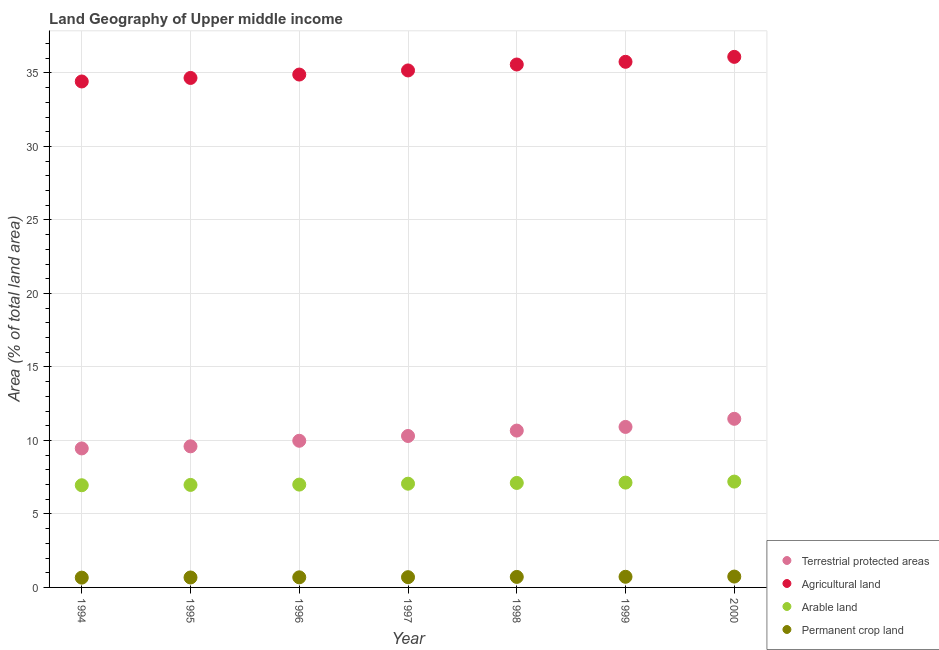How many different coloured dotlines are there?
Ensure brevity in your answer.  4. Is the number of dotlines equal to the number of legend labels?
Provide a short and direct response. Yes. What is the percentage of area under agricultural land in 2000?
Ensure brevity in your answer.  36.09. Across all years, what is the maximum percentage of land under terrestrial protection?
Your response must be concise. 11.47. Across all years, what is the minimum percentage of area under agricultural land?
Keep it short and to the point. 34.42. In which year was the percentage of area under agricultural land maximum?
Your response must be concise. 2000. In which year was the percentage of area under agricultural land minimum?
Make the answer very short. 1994. What is the total percentage of area under permanent crop land in the graph?
Your answer should be very brief. 4.9. What is the difference between the percentage of land under terrestrial protection in 1994 and that in 2000?
Ensure brevity in your answer.  -2.01. What is the difference between the percentage of land under terrestrial protection in 1997 and the percentage of area under arable land in 1996?
Provide a short and direct response. 3.31. What is the average percentage of area under permanent crop land per year?
Make the answer very short. 0.7. In the year 1998, what is the difference between the percentage of land under terrestrial protection and percentage of area under permanent crop land?
Ensure brevity in your answer.  9.95. What is the ratio of the percentage of area under permanent crop land in 1995 to that in 2000?
Offer a very short reply. 0.92. Is the difference between the percentage of area under agricultural land in 1996 and 1999 greater than the difference between the percentage of land under terrestrial protection in 1996 and 1999?
Make the answer very short. Yes. What is the difference between the highest and the second highest percentage of land under terrestrial protection?
Your answer should be very brief. 0.55. What is the difference between the highest and the lowest percentage of area under arable land?
Provide a succinct answer. 0.25. In how many years, is the percentage of land under terrestrial protection greater than the average percentage of land under terrestrial protection taken over all years?
Give a very brief answer. 3. Is the sum of the percentage of area under agricultural land in 1994 and 1997 greater than the maximum percentage of area under arable land across all years?
Provide a succinct answer. Yes. Is it the case that in every year, the sum of the percentage of area under agricultural land and percentage of area under permanent crop land is greater than the sum of percentage of land under terrestrial protection and percentage of area under arable land?
Make the answer very short. Yes. Is it the case that in every year, the sum of the percentage of land under terrestrial protection and percentage of area under agricultural land is greater than the percentage of area under arable land?
Provide a short and direct response. Yes. Is the percentage of area under agricultural land strictly less than the percentage of land under terrestrial protection over the years?
Offer a terse response. No. How many years are there in the graph?
Offer a terse response. 7. Are the values on the major ticks of Y-axis written in scientific E-notation?
Ensure brevity in your answer.  No. Does the graph contain any zero values?
Offer a very short reply. No. Does the graph contain grids?
Offer a very short reply. Yes. Where does the legend appear in the graph?
Make the answer very short. Bottom right. What is the title of the graph?
Offer a very short reply. Land Geography of Upper middle income. What is the label or title of the X-axis?
Provide a succinct answer. Year. What is the label or title of the Y-axis?
Offer a terse response. Area (% of total land area). What is the Area (% of total land area) of Terrestrial protected areas in 1994?
Offer a terse response. 9.46. What is the Area (% of total land area) in Agricultural land in 1994?
Make the answer very short. 34.42. What is the Area (% of total land area) of Arable land in 1994?
Offer a terse response. 6.95. What is the Area (% of total land area) in Permanent crop land in 1994?
Keep it short and to the point. 0.67. What is the Area (% of total land area) of Terrestrial protected areas in 1995?
Ensure brevity in your answer.  9.6. What is the Area (% of total land area) in Agricultural land in 1995?
Offer a terse response. 34.66. What is the Area (% of total land area) in Arable land in 1995?
Your answer should be compact. 6.97. What is the Area (% of total land area) in Permanent crop land in 1995?
Your response must be concise. 0.68. What is the Area (% of total land area) in Terrestrial protected areas in 1996?
Keep it short and to the point. 9.98. What is the Area (% of total land area) in Agricultural land in 1996?
Your answer should be compact. 34.89. What is the Area (% of total land area) of Arable land in 1996?
Offer a very short reply. 7. What is the Area (% of total land area) of Permanent crop land in 1996?
Provide a short and direct response. 0.69. What is the Area (% of total land area) in Terrestrial protected areas in 1997?
Provide a short and direct response. 10.3. What is the Area (% of total land area) in Agricultural land in 1997?
Ensure brevity in your answer.  35.17. What is the Area (% of total land area) in Arable land in 1997?
Your response must be concise. 7.06. What is the Area (% of total land area) of Permanent crop land in 1997?
Offer a terse response. 0.7. What is the Area (% of total land area) in Terrestrial protected areas in 1998?
Give a very brief answer. 10.67. What is the Area (% of total land area) of Agricultural land in 1998?
Your answer should be compact. 35.57. What is the Area (% of total land area) in Arable land in 1998?
Make the answer very short. 7.11. What is the Area (% of total land area) in Permanent crop land in 1998?
Offer a terse response. 0.72. What is the Area (% of total land area) of Terrestrial protected areas in 1999?
Provide a succinct answer. 10.92. What is the Area (% of total land area) of Agricultural land in 1999?
Keep it short and to the point. 35.76. What is the Area (% of total land area) of Arable land in 1999?
Offer a very short reply. 7.13. What is the Area (% of total land area) in Permanent crop land in 1999?
Keep it short and to the point. 0.72. What is the Area (% of total land area) in Terrestrial protected areas in 2000?
Offer a terse response. 11.47. What is the Area (% of total land area) in Agricultural land in 2000?
Keep it short and to the point. 36.09. What is the Area (% of total land area) in Arable land in 2000?
Keep it short and to the point. 7.2. What is the Area (% of total land area) of Permanent crop land in 2000?
Ensure brevity in your answer.  0.74. Across all years, what is the maximum Area (% of total land area) of Terrestrial protected areas?
Offer a very short reply. 11.47. Across all years, what is the maximum Area (% of total land area) of Agricultural land?
Your answer should be compact. 36.09. Across all years, what is the maximum Area (% of total land area) of Arable land?
Your answer should be compact. 7.2. Across all years, what is the maximum Area (% of total land area) of Permanent crop land?
Ensure brevity in your answer.  0.74. Across all years, what is the minimum Area (% of total land area) in Terrestrial protected areas?
Your answer should be compact. 9.46. Across all years, what is the minimum Area (% of total land area) in Agricultural land?
Offer a very short reply. 34.42. Across all years, what is the minimum Area (% of total land area) of Arable land?
Your answer should be very brief. 6.95. Across all years, what is the minimum Area (% of total land area) of Permanent crop land?
Your response must be concise. 0.67. What is the total Area (% of total land area) in Terrestrial protected areas in the graph?
Provide a short and direct response. 72.39. What is the total Area (% of total land area) in Agricultural land in the graph?
Your answer should be compact. 246.56. What is the total Area (% of total land area) in Arable land in the graph?
Give a very brief answer. 49.42. What is the total Area (% of total land area) of Permanent crop land in the graph?
Make the answer very short. 4.9. What is the difference between the Area (% of total land area) in Terrestrial protected areas in 1994 and that in 1995?
Ensure brevity in your answer.  -0.14. What is the difference between the Area (% of total land area) in Agricultural land in 1994 and that in 1995?
Make the answer very short. -0.24. What is the difference between the Area (% of total land area) of Arable land in 1994 and that in 1995?
Offer a very short reply. -0.02. What is the difference between the Area (% of total land area) of Permanent crop land in 1994 and that in 1995?
Provide a succinct answer. -0.01. What is the difference between the Area (% of total land area) in Terrestrial protected areas in 1994 and that in 1996?
Your response must be concise. -0.52. What is the difference between the Area (% of total land area) in Agricultural land in 1994 and that in 1996?
Give a very brief answer. -0.47. What is the difference between the Area (% of total land area) in Arable land in 1994 and that in 1996?
Ensure brevity in your answer.  -0.04. What is the difference between the Area (% of total land area) in Permanent crop land in 1994 and that in 1996?
Give a very brief answer. -0.02. What is the difference between the Area (% of total land area) of Terrestrial protected areas in 1994 and that in 1997?
Provide a short and direct response. -0.85. What is the difference between the Area (% of total land area) in Agricultural land in 1994 and that in 1997?
Provide a succinct answer. -0.75. What is the difference between the Area (% of total land area) in Arable land in 1994 and that in 1997?
Your answer should be compact. -0.11. What is the difference between the Area (% of total land area) of Permanent crop land in 1994 and that in 1997?
Offer a very short reply. -0.03. What is the difference between the Area (% of total land area) of Terrestrial protected areas in 1994 and that in 1998?
Offer a very short reply. -1.21. What is the difference between the Area (% of total land area) of Agricultural land in 1994 and that in 1998?
Ensure brevity in your answer.  -1.15. What is the difference between the Area (% of total land area) in Arable land in 1994 and that in 1998?
Make the answer very short. -0.16. What is the difference between the Area (% of total land area) of Permanent crop land in 1994 and that in 1998?
Your response must be concise. -0.05. What is the difference between the Area (% of total land area) of Terrestrial protected areas in 1994 and that in 1999?
Provide a short and direct response. -1.46. What is the difference between the Area (% of total land area) in Agricultural land in 1994 and that in 1999?
Provide a short and direct response. -1.34. What is the difference between the Area (% of total land area) of Arable land in 1994 and that in 1999?
Ensure brevity in your answer.  -0.18. What is the difference between the Area (% of total land area) of Permanent crop land in 1994 and that in 1999?
Give a very brief answer. -0.06. What is the difference between the Area (% of total land area) in Terrestrial protected areas in 1994 and that in 2000?
Provide a short and direct response. -2.01. What is the difference between the Area (% of total land area) of Agricultural land in 1994 and that in 2000?
Make the answer very short. -1.67. What is the difference between the Area (% of total land area) of Arable land in 1994 and that in 2000?
Your response must be concise. -0.25. What is the difference between the Area (% of total land area) in Permanent crop land in 1994 and that in 2000?
Offer a very short reply. -0.07. What is the difference between the Area (% of total land area) of Terrestrial protected areas in 1995 and that in 1996?
Offer a terse response. -0.38. What is the difference between the Area (% of total land area) in Agricultural land in 1995 and that in 1996?
Give a very brief answer. -0.23. What is the difference between the Area (% of total land area) of Arable land in 1995 and that in 1996?
Provide a succinct answer. -0.02. What is the difference between the Area (% of total land area) in Permanent crop land in 1995 and that in 1996?
Give a very brief answer. -0.01. What is the difference between the Area (% of total land area) of Terrestrial protected areas in 1995 and that in 1997?
Your answer should be compact. -0.7. What is the difference between the Area (% of total land area) of Agricultural land in 1995 and that in 1997?
Offer a very short reply. -0.51. What is the difference between the Area (% of total land area) of Arable land in 1995 and that in 1997?
Ensure brevity in your answer.  -0.08. What is the difference between the Area (% of total land area) of Permanent crop land in 1995 and that in 1997?
Make the answer very short. -0.02. What is the difference between the Area (% of total land area) of Terrestrial protected areas in 1995 and that in 1998?
Offer a very short reply. -1.07. What is the difference between the Area (% of total land area) in Agricultural land in 1995 and that in 1998?
Your answer should be very brief. -0.91. What is the difference between the Area (% of total land area) of Arable land in 1995 and that in 1998?
Give a very brief answer. -0.13. What is the difference between the Area (% of total land area) of Permanent crop land in 1995 and that in 1998?
Your answer should be very brief. -0.04. What is the difference between the Area (% of total land area) in Terrestrial protected areas in 1995 and that in 1999?
Provide a succinct answer. -1.32. What is the difference between the Area (% of total land area) of Agricultural land in 1995 and that in 1999?
Your answer should be very brief. -1.1. What is the difference between the Area (% of total land area) in Arable land in 1995 and that in 1999?
Your response must be concise. -0.16. What is the difference between the Area (% of total land area) in Permanent crop land in 1995 and that in 1999?
Keep it short and to the point. -0.05. What is the difference between the Area (% of total land area) of Terrestrial protected areas in 1995 and that in 2000?
Offer a terse response. -1.87. What is the difference between the Area (% of total land area) of Agricultural land in 1995 and that in 2000?
Make the answer very short. -1.43. What is the difference between the Area (% of total land area) in Arable land in 1995 and that in 2000?
Ensure brevity in your answer.  -0.23. What is the difference between the Area (% of total land area) in Permanent crop land in 1995 and that in 2000?
Provide a succinct answer. -0.06. What is the difference between the Area (% of total land area) of Terrestrial protected areas in 1996 and that in 1997?
Provide a succinct answer. -0.33. What is the difference between the Area (% of total land area) in Agricultural land in 1996 and that in 1997?
Your answer should be very brief. -0.28. What is the difference between the Area (% of total land area) of Arable land in 1996 and that in 1997?
Your answer should be very brief. -0.06. What is the difference between the Area (% of total land area) in Permanent crop land in 1996 and that in 1997?
Your answer should be very brief. -0.01. What is the difference between the Area (% of total land area) of Terrestrial protected areas in 1996 and that in 1998?
Give a very brief answer. -0.69. What is the difference between the Area (% of total land area) in Agricultural land in 1996 and that in 1998?
Offer a terse response. -0.68. What is the difference between the Area (% of total land area) in Arable land in 1996 and that in 1998?
Provide a short and direct response. -0.11. What is the difference between the Area (% of total land area) of Permanent crop land in 1996 and that in 1998?
Offer a terse response. -0.03. What is the difference between the Area (% of total land area) in Terrestrial protected areas in 1996 and that in 1999?
Offer a terse response. -0.94. What is the difference between the Area (% of total land area) of Agricultural land in 1996 and that in 1999?
Your answer should be very brief. -0.87. What is the difference between the Area (% of total land area) in Arable land in 1996 and that in 1999?
Keep it short and to the point. -0.14. What is the difference between the Area (% of total land area) in Permanent crop land in 1996 and that in 1999?
Your answer should be very brief. -0.04. What is the difference between the Area (% of total land area) of Terrestrial protected areas in 1996 and that in 2000?
Offer a very short reply. -1.49. What is the difference between the Area (% of total land area) of Agricultural land in 1996 and that in 2000?
Keep it short and to the point. -1.2. What is the difference between the Area (% of total land area) in Arable land in 1996 and that in 2000?
Your answer should be compact. -0.2. What is the difference between the Area (% of total land area) of Permanent crop land in 1996 and that in 2000?
Ensure brevity in your answer.  -0.05. What is the difference between the Area (% of total land area) in Terrestrial protected areas in 1997 and that in 1998?
Ensure brevity in your answer.  -0.37. What is the difference between the Area (% of total land area) in Agricultural land in 1997 and that in 1998?
Your answer should be compact. -0.4. What is the difference between the Area (% of total land area) of Arable land in 1997 and that in 1998?
Your response must be concise. -0.05. What is the difference between the Area (% of total land area) of Permanent crop land in 1997 and that in 1998?
Ensure brevity in your answer.  -0.02. What is the difference between the Area (% of total land area) in Terrestrial protected areas in 1997 and that in 1999?
Make the answer very short. -0.62. What is the difference between the Area (% of total land area) of Agricultural land in 1997 and that in 1999?
Offer a very short reply. -0.59. What is the difference between the Area (% of total land area) of Arable land in 1997 and that in 1999?
Your response must be concise. -0.07. What is the difference between the Area (% of total land area) in Permanent crop land in 1997 and that in 1999?
Your answer should be compact. -0.03. What is the difference between the Area (% of total land area) of Terrestrial protected areas in 1997 and that in 2000?
Provide a succinct answer. -1.17. What is the difference between the Area (% of total land area) of Agricultural land in 1997 and that in 2000?
Make the answer very short. -0.92. What is the difference between the Area (% of total land area) of Arable land in 1997 and that in 2000?
Your answer should be compact. -0.14. What is the difference between the Area (% of total land area) in Permanent crop land in 1997 and that in 2000?
Give a very brief answer. -0.04. What is the difference between the Area (% of total land area) of Terrestrial protected areas in 1998 and that in 1999?
Offer a very short reply. -0.25. What is the difference between the Area (% of total land area) in Agricultural land in 1998 and that in 1999?
Keep it short and to the point. -0.18. What is the difference between the Area (% of total land area) in Arable land in 1998 and that in 1999?
Provide a succinct answer. -0.02. What is the difference between the Area (% of total land area) in Permanent crop land in 1998 and that in 1999?
Your answer should be compact. -0.01. What is the difference between the Area (% of total land area) in Terrestrial protected areas in 1998 and that in 2000?
Your answer should be very brief. -0.8. What is the difference between the Area (% of total land area) in Agricultural land in 1998 and that in 2000?
Your answer should be very brief. -0.52. What is the difference between the Area (% of total land area) of Arable land in 1998 and that in 2000?
Your response must be concise. -0.09. What is the difference between the Area (% of total land area) of Permanent crop land in 1998 and that in 2000?
Keep it short and to the point. -0.02. What is the difference between the Area (% of total land area) of Terrestrial protected areas in 1999 and that in 2000?
Offer a very short reply. -0.55. What is the difference between the Area (% of total land area) of Agricultural land in 1999 and that in 2000?
Make the answer very short. -0.34. What is the difference between the Area (% of total land area) in Arable land in 1999 and that in 2000?
Your answer should be compact. -0.07. What is the difference between the Area (% of total land area) of Permanent crop land in 1999 and that in 2000?
Offer a very short reply. -0.02. What is the difference between the Area (% of total land area) in Terrestrial protected areas in 1994 and the Area (% of total land area) in Agricultural land in 1995?
Your answer should be compact. -25.2. What is the difference between the Area (% of total land area) of Terrestrial protected areas in 1994 and the Area (% of total land area) of Arable land in 1995?
Keep it short and to the point. 2.48. What is the difference between the Area (% of total land area) of Terrestrial protected areas in 1994 and the Area (% of total land area) of Permanent crop land in 1995?
Your response must be concise. 8.78. What is the difference between the Area (% of total land area) in Agricultural land in 1994 and the Area (% of total land area) in Arable land in 1995?
Give a very brief answer. 27.44. What is the difference between the Area (% of total land area) in Agricultural land in 1994 and the Area (% of total land area) in Permanent crop land in 1995?
Your response must be concise. 33.74. What is the difference between the Area (% of total land area) of Arable land in 1994 and the Area (% of total land area) of Permanent crop land in 1995?
Provide a short and direct response. 6.27. What is the difference between the Area (% of total land area) of Terrestrial protected areas in 1994 and the Area (% of total land area) of Agricultural land in 1996?
Offer a very short reply. -25.43. What is the difference between the Area (% of total land area) of Terrestrial protected areas in 1994 and the Area (% of total land area) of Arable land in 1996?
Ensure brevity in your answer.  2.46. What is the difference between the Area (% of total land area) in Terrestrial protected areas in 1994 and the Area (% of total land area) in Permanent crop land in 1996?
Offer a terse response. 8.77. What is the difference between the Area (% of total land area) in Agricultural land in 1994 and the Area (% of total land area) in Arable land in 1996?
Give a very brief answer. 27.42. What is the difference between the Area (% of total land area) of Agricultural land in 1994 and the Area (% of total land area) of Permanent crop land in 1996?
Give a very brief answer. 33.73. What is the difference between the Area (% of total land area) in Arable land in 1994 and the Area (% of total land area) in Permanent crop land in 1996?
Keep it short and to the point. 6.26. What is the difference between the Area (% of total land area) in Terrestrial protected areas in 1994 and the Area (% of total land area) in Agricultural land in 1997?
Provide a succinct answer. -25.71. What is the difference between the Area (% of total land area) in Terrestrial protected areas in 1994 and the Area (% of total land area) in Arable land in 1997?
Give a very brief answer. 2.4. What is the difference between the Area (% of total land area) in Terrestrial protected areas in 1994 and the Area (% of total land area) in Permanent crop land in 1997?
Make the answer very short. 8.76. What is the difference between the Area (% of total land area) of Agricultural land in 1994 and the Area (% of total land area) of Arable land in 1997?
Make the answer very short. 27.36. What is the difference between the Area (% of total land area) in Agricultural land in 1994 and the Area (% of total land area) in Permanent crop land in 1997?
Your answer should be compact. 33.72. What is the difference between the Area (% of total land area) in Arable land in 1994 and the Area (% of total land area) in Permanent crop land in 1997?
Ensure brevity in your answer.  6.25. What is the difference between the Area (% of total land area) of Terrestrial protected areas in 1994 and the Area (% of total land area) of Agricultural land in 1998?
Offer a terse response. -26.12. What is the difference between the Area (% of total land area) in Terrestrial protected areas in 1994 and the Area (% of total land area) in Arable land in 1998?
Your answer should be compact. 2.35. What is the difference between the Area (% of total land area) in Terrestrial protected areas in 1994 and the Area (% of total land area) in Permanent crop land in 1998?
Ensure brevity in your answer.  8.74. What is the difference between the Area (% of total land area) of Agricultural land in 1994 and the Area (% of total land area) of Arable land in 1998?
Your answer should be very brief. 27.31. What is the difference between the Area (% of total land area) in Agricultural land in 1994 and the Area (% of total land area) in Permanent crop land in 1998?
Your response must be concise. 33.7. What is the difference between the Area (% of total land area) of Arable land in 1994 and the Area (% of total land area) of Permanent crop land in 1998?
Offer a terse response. 6.24. What is the difference between the Area (% of total land area) in Terrestrial protected areas in 1994 and the Area (% of total land area) in Agricultural land in 1999?
Give a very brief answer. -26.3. What is the difference between the Area (% of total land area) in Terrestrial protected areas in 1994 and the Area (% of total land area) in Arable land in 1999?
Your answer should be compact. 2.32. What is the difference between the Area (% of total land area) in Terrestrial protected areas in 1994 and the Area (% of total land area) in Permanent crop land in 1999?
Your answer should be very brief. 8.73. What is the difference between the Area (% of total land area) of Agricultural land in 1994 and the Area (% of total land area) of Arable land in 1999?
Give a very brief answer. 27.29. What is the difference between the Area (% of total land area) in Agricultural land in 1994 and the Area (% of total land area) in Permanent crop land in 1999?
Give a very brief answer. 33.69. What is the difference between the Area (% of total land area) in Arable land in 1994 and the Area (% of total land area) in Permanent crop land in 1999?
Ensure brevity in your answer.  6.23. What is the difference between the Area (% of total land area) in Terrestrial protected areas in 1994 and the Area (% of total land area) in Agricultural land in 2000?
Offer a terse response. -26.64. What is the difference between the Area (% of total land area) of Terrestrial protected areas in 1994 and the Area (% of total land area) of Arable land in 2000?
Ensure brevity in your answer.  2.26. What is the difference between the Area (% of total land area) in Terrestrial protected areas in 1994 and the Area (% of total land area) in Permanent crop land in 2000?
Provide a short and direct response. 8.72. What is the difference between the Area (% of total land area) in Agricultural land in 1994 and the Area (% of total land area) in Arable land in 2000?
Your answer should be very brief. 27.22. What is the difference between the Area (% of total land area) of Agricultural land in 1994 and the Area (% of total land area) of Permanent crop land in 2000?
Offer a terse response. 33.68. What is the difference between the Area (% of total land area) of Arable land in 1994 and the Area (% of total land area) of Permanent crop land in 2000?
Your answer should be compact. 6.21. What is the difference between the Area (% of total land area) of Terrestrial protected areas in 1995 and the Area (% of total land area) of Agricultural land in 1996?
Offer a very short reply. -25.29. What is the difference between the Area (% of total land area) of Terrestrial protected areas in 1995 and the Area (% of total land area) of Arable land in 1996?
Keep it short and to the point. 2.6. What is the difference between the Area (% of total land area) of Terrestrial protected areas in 1995 and the Area (% of total land area) of Permanent crop land in 1996?
Give a very brief answer. 8.91. What is the difference between the Area (% of total land area) in Agricultural land in 1995 and the Area (% of total land area) in Arable land in 1996?
Keep it short and to the point. 27.66. What is the difference between the Area (% of total land area) in Agricultural land in 1995 and the Area (% of total land area) in Permanent crop land in 1996?
Make the answer very short. 33.97. What is the difference between the Area (% of total land area) of Arable land in 1995 and the Area (% of total land area) of Permanent crop land in 1996?
Provide a short and direct response. 6.29. What is the difference between the Area (% of total land area) in Terrestrial protected areas in 1995 and the Area (% of total land area) in Agricultural land in 1997?
Make the answer very short. -25.57. What is the difference between the Area (% of total land area) of Terrestrial protected areas in 1995 and the Area (% of total land area) of Arable land in 1997?
Offer a very short reply. 2.54. What is the difference between the Area (% of total land area) of Terrestrial protected areas in 1995 and the Area (% of total land area) of Permanent crop land in 1997?
Keep it short and to the point. 8.9. What is the difference between the Area (% of total land area) of Agricultural land in 1995 and the Area (% of total land area) of Arable land in 1997?
Offer a terse response. 27.6. What is the difference between the Area (% of total land area) in Agricultural land in 1995 and the Area (% of total land area) in Permanent crop land in 1997?
Offer a very short reply. 33.96. What is the difference between the Area (% of total land area) in Arable land in 1995 and the Area (% of total land area) in Permanent crop land in 1997?
Your answer should be very brief. 6.28. What is the difference between the Area (% of total land area) of Terrestrial protected areas in 1995 and the Area (% of total land area) of Agricultural land in 1998?
Ensure brevity in your answer.  -25.97. What is the difference between the Area (% of total land area) in Terrestrial protected areas in 1995 and the Area (% of total land area) in Arable land in 1998?
Provide a succinct answer. 2.49. What is the difference between the Area (% of total land area) in Terrestrial protected areas in 1995 and the Area (% of total land area) in Permanent crop land in 1998?
Keep it short and to the point. 8.88. What is the difference between the Area (% of total land area) of Agricultural land in 1995 and the Area (% of total land area) of Arable land in 1998?
Offer a very short reply. 27.55. What is the difference between the Area (% of total land area) of Agricultural land in 1995 and the Area (% of total land area) of Permanent crop land in 1998?
Ensure brevity in your answer.  33.94. What is the difference between the Area (% of total land area) of Arable land in 1995 and the Area (% of total land area) of Permanent crop land in 1998?
Keep it short and to the point. 6.26. What is the difference between the Area (% of total land area) in Terrestrial protected areas in 1995 and the Area (% of total land area) in Agricultural land in 1999?
Ensure brevity in your answer.  -26.16. What is the difference between the Area (% of total land area) of Terrestrial protected areas in 1995 and the Area (% of total land area) of Arable land in 1999?
Provide a short and direct response. 2.47. What is the difference between the Area (% of total land area) of Terrestrial protected areas in 1995 and the Area (% of total land area) of Permanent crop land in 1999?
Provide a succinct answer. 8.87. What is the difference between the Area (% of total land area) of Agricultural land in 1995 and the Area (% of total land area) of Arable land in 1999?
Ensure brevity in your answer.  27.53. What is the difference between the Area (% of total land area) of Agricultural land in 1995 and the Area (% of total land area) of Permanent crop land in 1999?
Your response must be concise. 33.93. What is the difference between the Area (% of total land area) in Arable land in 1995 and the Area (% of total land area) in Permanent crop land in 1999?
Offer a terse response. 6.25. What is the difference between the Area (% of total land area) of Terrestrial protected areas in 1995 and the Area (% of total land area) of Agricultural land in 2000?
Give a very brief answer. -26.49. What is the difference between the Area (% of total land area) of Terrestrial protected areas in 1995 and the Area (% of total land area) of Arable land in 2000?
Offer a very short reply. 2.4. What is the difference between the Area (% of total land area) in Terrestrial protected areas in 1995 and the Area (% of total land area) in Permanent crop land in 2000?
Offer a terse response. 8.86. What is the difference between the Area (% of total land area) in Agricultural land in 1995 and the Area (% of total land area) in Arable land in 2000?
Give a very brief answer. 27.46. What is the difference between the Area (% of total land area) of Agricultural land in 1995 and the Area (% of total land area) of Permanent crop land in 2000?
Provide a succinct answer. 33.92. What is the difference between the Area (% of total land area) of Arable land in 1995 and the Area (% of total land area) of Permanent crop land in 2000?
Make the answer very short. 6.23. What is the difference between the Area (% of total land area) in Terrestrial protected areas in 1996 and the Area (% of total land area) in Agricultural land in 1997?
Your answer should be very brief. -25.19. What is the difference between the Area (% of total land area) of Terrestrial protected areas in 1996 and the Area (% of total land area) of Arable land in 1997?
Offer a terse response. 2.92. What is the difference between the Area (% of total land area) in Terrestrial protected areas in 1996 and the Area (% of total land area) in Permanent crop land in 1997?
Make the answer very short. 9.28. What is the difference between the Area (% of total land area) in Agricultural land in 1996 and the Area (% of total land area) in Arable land in 1997?
Offer a very short reply. 27.83. What is the difference between the Area (% of total land area) in Agricultural land in 1996 and the Area (% of total land area) in Permanent crop land in 1997?
Offer a very short reply. 34.19. What is the difference between the Area (% of total land area) of Arable land in 1996 and the Area (% of total land area) of Permanent crop land in 1997?
Offer a very short reply. 6.3. What is the difference between the Area (% of total land area) of Terrestrial protected areas in 1996 and the Area (% of total land area) of Agricultural land in 1998?
Your answer should be very brief. -25.6. What is the difference between the Area (% of total land area) of Terrestrial protected areas in 1996 and the Area (% of total land area) of Arable land in 1998?
Keep it short and to the point. 2.87. What is the difference between the Area (% of total land area) in Terrestrial protected areas in 1996 and the Area (% of total land area) in Permanent crop land in 1998?
Provide a short and direct response. 9.26. What is the difference between the Area (% of total land area) of Agricultural land in 1996 and the Area (% of total land area) of Arable land in 1998?
Offer a terse response. 27.78. What is the difference between the Area (% of total land area) of Agricultural land in 1996 and the Area (% of total land area) of Permanent crop land in 1998?
Ensure brevity in your answer.  34.17. What is the difference between the Area (% of total land area) of Arable land in 1996 and the Area (% of total land area) of Permanent crop land in 1998?
Ensure brevity in your answer.  6.28. What is the difference between the Area (% of total land area) of Terrestrial protected areas in 1996 and the Area (% of total land area) of Agricultural land in 1999?
Give a very brief answer. -25.78. What is the difference between the Area (% of total land area) of Terrestrial protected areas in 1996 and the Area (% of total land area) of Arable land in 1999?
Your answer should be compact. 2.84. What is the difference between the Area (% of total land area) of Terrestrial protected areas in 1996 and the Area (% of total land area) of Permanent crop land in 1999?
Provide a short and direct response. 9.25. What is the difference between the Area (% of total land area) of Agricultural land in 1996 and the Area (% of total land area) of Arable land in 1999?
Offer a terse response. 27.76. What is the difference between the Area (% of total land area) of Agricultural land in 1996 and the Area (% of total land area) of Permanent crop land in 1999?
Ensure brevity in your answer.  34.16. What is the difference between the Area (% of total land area) of Arable land in 1996 and the Area (% of total land area) of Permanent crop land in 1999?
Your response must be concise. 6.27. What is the difference between the Area (% of total land area) in Terrestrial protected areas in 1996 and the Area (% of total land area) in Agricultural land in 2000?
Your answer should be very brief. -26.12. What is the difference between the Area (% of total land area) of Terrestrial protected areas in 1996 and the Area (% of total land area) of Arable land in 2000?
Give a very brief answer. 2.78. What is the difference between the Area (% of total land area) of Terrestrial protected areas in 1996 and the Area (% of total land area) of Permanent crop land in 2000?
Offer a very short reply. 9.24. What is the difference between the Area (% of total land area) in Agricultural land in 1996 and the Area (% of total land area) in Arable land in 2000?
Offer a very short reply. 27.69. What is the difference between the Area (% of total land area) of Agricultural land in 1996 and the Area (% of total land area) of Permanent crop land in 2000?
Ensure brevity in your answer.  34.15. What is the difference between the Area (% of total land area) in Arable land in 1996 and the Area (% of total land area) in Permanent crop land in 2000?
Provide a short and direct response. 6.26. What is the difference between the Area (% of total land area) in Terrestrial protected areas in 1997 and the Area (% of total land area) in Agricultural land in 1998?
Give a very brief answer. -25.27. What is the difference between the Area (% of total land area) of Terrestrial protected areas in 1997 and the Area (% of total land area) of Arable land in 1998?
Offer a terse response. 3.19. What is the difference between the Area (% of total land area) of Terrestrial protected areas in 1997 and the Area (% of total land area) of Permanent crop land in 1998?
Provide a short and direct response. 9.59. What is the difference between the Area (% of total land area) in Agricultural land in 1997 and the Area (% of total land area) in Arable land in 1998?
Your answer should be compact. 28.06. What is the difference between the Area (% of total land area) in Agricultural land in 1997 and the Area (% of total land area) in Permanent crop land in 1998?
Your answer should be compact. 34.45. What is the difference between the Area (% of total land area) in Arable land in 1997 and the Area (% of total land area) in Permanent crop land in 1998?
Provide a succinct answer. 6.34. What is the difference between the Area (% of total land area) of Terrestrial protected areas in 1997 and the Area (% of total land area) of Agricultural land in 1999?
Offer a terse response. -25.45. What is the difference between the Area (% of total land area) of Terrestrial protected areas in 1997 and the Area (% of total land area) of Arable land in 1999?
Your response must be concise. 3.17. What is the difference between the Area (% of total land area) of Terrestrial protected areas in 1997 and the Area (% of total land area) of Permanent crop land in 1999?
Provide a short and direct response. 9.58. What is the difference between the Area (% of total land area) of Agricultural land in 1997 and the Area (% of total land area) of Arable land in 1999?
Provide a succinct answer. 28.04. What is the difference between the Area (% of total land area) of Agricultural land in 1997 and the Area (% of total land area) of Permanent crop land in 1999?
Make the answer very short. 34.45. What is the difference between the Area (% of total land area) in Arable land in 1997 and the Area (% of total land area) in Permanent crop land in 1999?
Give a very brief answer. 6.33. What is the difference between the Area (% of total land area) of Terrestrial protected areas in 1997 and the Area (% of total land area) of Agricultural land in 2000?
Make the answer very short. -25.79. What is the difference between the Area (% of total land area) of Terrestrial protected areas in 1997 and the Area (% of total land area) of Arable land in 2000?
Offer a terse response. 3.1. What is the difference between the Area (% of total land area) in Terrestrial protected areas in 1997 and the Area (% of total land area) in Permanent crop land in 2000?
Provide a short and direct response. 9.56. What is the difference between the Area (% of total land area) in Agricultural land in 1997 and the Area (% of total land area) in Arable land in 2000?
Make the answer very short. 27.97. What is the difference between the Area (% of total land area) in Agricultural land in 1997 and the Area (% of total land area) in Permanent crop land in 2000?
Your answer should be very brief. 34.43. What is the difference between the Area (% of total land area) of Arable land in 1997 and the Area (% of total land area) of Permanent crop land in 2000?
Make the answer very short. 6.32. What is the difference between the Area (% of total land area) of Terrestrial protected areas in 1998 and the Area (% of total land area) of Agricultural land in 1999?
Provide a short and direct response. -25.09. What is the difference between the Area (% of total land area) of Terrestrial protected areas in 1998 and the Area (% of total land area) of Arable land in 1999?
Ensure brevity in your answer.  3.54. What is the difference between the Area (% of total land area) in Terrestrial protected areas in 1998 and the Area (% of total land area) in Permanent crop land in 1999?
Offer a very short reply. 9.95. What is the difference between the Area (% of total land area) in Agricultural land in 1998 and the Area (% of total land area) in Arable land in 1999?
Offer a very short reply. 28.44. What is the difference between the Area (% of total land area) in Agricultural land in 1998 and the Area (% of total land area) in Permanent crop land in 1999?
Your answer should be compact. 34.85. What is the difference between the Area (% of total land area) of Arable land in 1998 and the Area (% of total land area) of Permanent crop land in 1999?
Provide a short and direct response. 6.38. What is the difference between the Area (% of total land area) in Terrestrial protected areas in 1998 and the Area (% of total land area) in Agricultural land in 2000?
Make the answer very short. -25.42. What is the difference between the Area (% of total land area) in Terrestrial protected areas in 1998 and the Area (% of total land area) in Arable land in 2000?
Your answer should be very brief. 3.47. What is the difference between the Area (% of total land area) in Terrestrial protected areas in 1998 and the Area (% of total land area) in Permanent crop land in 2000?
Give a very brief answer. 9.93. What is the difference between the Area (% of total land area) of Agricultural land in 1998 and the Area (% of total land area) of Arable land in 2000?
Offer a very short reply. 28.37. What is the difference between the Area (% of total land area) in Agricultural land in 1998 and the Area (% of total land area) in Permanent crop land in 2000?
Keep it short and to the point. 34.83. What is the difference between the Area (% of total land area) of Arable land in 1998 and the Area (% of total land area) of Permanent crop land in 2000?
Provide a succinct answer. 6.37. What is the difference between the Area (% of total land area) in Terrestrial protected areas in 1999 and the Area (% of total land area) in Agricultural land in 2000?
Ensure brevity in your answer.  -25.17. What is the difference between the Area (% of total land area) in Terrestrial protected areas in 1999 and the Area (% of total land area) in Arable land in 2000?
Give a very brief answer. 3.72. What is the difference between the Area (% of total land area) of Terrestrial protected areas in 1999 and the Area (% of total land area) of Permanent crop land in 2000?
Your answer should be compact. 10.18. What is the difference between the Area (% of total land area) of Agricultural land in 1999 and the Area (% of total land area) of Arable land in 2000?
Keep it short and to the point. 28.56. What is the difference between the Area (% of total land area) of Agricultural land in 1999 and the Area (% of total land area) of Permanent crop land in 2000?
Keep it short and to the point. 35.02. What is the difference between the Area (% of total land area) in Arable land in 1999 and the Area (% of total land area) in Permanent crop land in 2000?
Offer a very short reply. 6.39. What is the average Area (% of total land area) in Terrestrial protected areas per year?
Your answer should be compact. 10.34. What is the average Area (% of total land area) in Agricultural land per year?
Provide a short and direct response. 35.22. What is the average Area (% of total land area) in Arable land per year?
Offer a very short reply. 7.06. What is the average Area (% of total land area) in Permanent crop land per year?
Provide a short and direct response. 0.7. In the year 1994, what is the difference between the Area (% of total land area) of Terrestrial protected areas and Area (% of total land area) of Agricultural land?
Your answer should be very brief. -24.96. In the year 1994, what is the difference between the Area (% of total land area) in Terrestrial protected areas and Area (% of total land area) in Arable land?
Offer a terse response. 2.5. In the year 1994, what is the difference between the Area (% of total land area) of Terrestrial protected areas and Area (% of total land area) of Permanent crop land?
Your answer should be compact. 8.79. In the year 1994, what is the difference between the Area (% of total land area) in Agricultural land and Area (% of total land area) in Arable land?
Provide a succinct answer. 27.47. In the year 1994, what is the difference between the Area (% of total land area) of Agricultural land and Area (% of total land area) of Permanent crop land?
Give a very brief answer. 33.75. In the year 1994, what is the difference between the Area (% of total land area) in Arable land and Area (% of total land area) in Permanent crop land?
Offer a terse response. 6.29. In the year 1995, what is the difference between the Area (% of total land area) of Terrestrial protected areas and Area (% of total land area) of Agricultural land?
Provide a succinct answer. -25.06. In the year 1995, what is the difference between the Area (% of total land area) of Terrestrial protected areas and Area (% of total land area) of Arable land?
Offer a terse response. 2.62. In the year 1995, what is the difference between the Area (% of total land area) in Terrestrial protected areas and Area (% of total land area) in Permanent crop land?
Make the answer very short. 8.92. In the year 1995, what is the difference between the Area (% of total land area) of Agricultural land and Area (% of total land area) of Arable land?
Your response must be concise. 27.68. In the year 1995, what is the difference between the Area (% of total land area) in Agricultural land and Area (% of total land area) in Permanent crop land?
Your response must be concise. 33.98. In the year 1995, what is the difference between the Area (% of total land area) of Arable land and Area (% of total land area) of Permanent crop land?
Your answer should be very brief. 6.3. In the year 1996, what is the difference between the Area (% of total land area) in Terrestrial protected areas and Area (% of total land area) in Agricultural land?
Offer a terse response. -24.91. In the year 1996, what is the difference between the Area (% of total land area) in Terrestrial protected areas and Area (% of total land area) in Arable land?
Your answer should be very brief. 2.98. In the year 1996, what is the difference between the Area (% of total land area) of Terrestrial protected areas and Area (% of total land area) of Permanent crop land?
Your answer should be compact. 9.29. In the year 1996, what is the difference between the Area (% of total land area) in Agricultural land and Area (% of total land area) in Arable land?
Provide a short and direct response. 27.89. In the year 1996, what is the difference between the Area (% of total land area) of Agricultural land and Area (% of total land area) of Permanent crop land?
Give a very brief answer. 34.2. In the year 1996, what is the difference between the Area (% of total land area) in Arable land and Area (% of total land area) in Permanent crop land?
Provide a succinct answer. 6.31. In the year 1997, what is the difference between the Area (% of total land area) in Terrestrial protected areas and Area (% of total land area) in Agricultural land?
Keep it short and to the point. -24.87. In the year 1997, what is the difference between the Area (% of total land area) in Terrestrial protected areas and Area (% of total land area) in Arable land?
Your answer should be compact. 3.24. In the year 1997, what is the difference between the Area (% of total land area) of Terrestrial protected areas and Area (% of total land area) of Permanent crop land?
Offer a very short reply. 9.6. In the year 1997, what is the difference between the Area (% of total land area) in Agricultural land and Area (% of total land area) in Arable land?
Provide a succinct answer. 28.11. In the year 1997, what is the difference between the Area (% of total land area) in Agricultural land and Area (% of total land area) in Permanent crop land?
Ensure brevity in your answer.  34.47. In the year 1997, what is the difference between the Area (% of total land area) of Arable land and Area (% of total land area) of Permanent crop land?
Your answer should be very brief. 6.36. In the year 1998, what is the difference between the Area (% of total land area) of Terrestrial protected areas and Area (% of total land area) of Agricultural land?
Your answer should be compact. -24.9. In the year 1998, what is the difference between the Area (% of total land area) of Terrestrial protected areas and Area (% of total land area) of Arable land?
Provide a short and direct response. 3.56. In the year 1998, what is the difference between the Area (% of total land area) in Terrestrial protected areas and Area (% of total land area) in Permanent crop land?
Make the answer very short. 9.95. In the year 1998, what is the difference between the Area (% of total land area) in Agricultural land and Area (% of total land area) in Arable land?
Offer a terse response. 28.46. In the year 1998, what is the difference between the Area (% of total land area) in Agricultural land and Area (% of total land area) in Permanent crop land?
Your response must be concise. 34.86. In the year 1998, what is the difference between the Area (% of total land area) of Arable land and Area (% of total land area) of Permanent crop land?
Provide a short and direct response. 6.39. In the year 1999, what is the difference between the Area (% of total land area) of Terrestrial protected areas and Area (% of total land area) of Agricultural land?
Offer a very short reply. -24.84. In the year 1999, what is the difference between the Area (% of total land area) in Terrestrial protected areas and Area (% of total land area) in Arable land?
Your answer should be very brief. 3.79. In the year 1999, what is the difference between the Area (% of total land area) in Terrestrial protected areas and Area (% of total land area) in Permanent crop land?
Keep it short and to the point. 10.19. In the year 1999, what is the difference between the Area (% of total land area) in Agricultural land and Area (% of total land area) in Arable land?
Keep it short and to the point. 28.63. In the year 1999, what is the difference between the Area (% of total land area) of Agricultural land and Area (% of total land area) of Permanent crop land?
Provide a succinct answer. 35.03. In the year 1999, what is the difference between the Area (% of total land area) of Arable land and Area (% of total land area) of Permanent crop land?
Your answer should be compact. 6.41. In the year 2000, what is the difference between the Area (% of total land area) of Terrestrial protected areas and Area (% of total land area) of Agricultural land?
Offer a very short reply. -24.62. In the year 2000, what is the difference between the Area (% of total land area) in Terrestrial protected areas and Area (% of total land area) in Arable land?
Your answer should be compact. 4.27. In the year 2000, what is the difference between the Area (% of total land area) in Terrestrial protected areas and Area (% of total land area) in Permanent crop land?
Ensure brevity in your answer.  10.73. In the year 2000, what is the difference between the Area (% of total land area) in Agricultural land and Area (% of total land area) in Arable land?
Keep it short and to the point. 28.89. In the year 2000, what is the difference between the Area (% of total land area) in Agricultural land and Area (% of total land area) in Permanent crop land?
Give a very brief answer. 35.35. In the year 2000, what is the difference between the Area (% of total land area) of Arable land and Area (% of total land area) of Permanent crop land?
Offer a terse response. 6.46. What is the ratio of the Area (% of total land area) in Terrestrial protected areas in 1994 to that in 1995?
Give a very brief answer. 0.99. What is the ratio of the Area (% of total land area) in Permanent crop land in 1994 to that in 1995?
Your answer should be very brief. 0.98. What is the ratio of the Area (% of total land area) of Terrestrial protected areas in 1994 to that in 1996?
Your answer should be compact. 0.95. What is the ratio of the Area (% of total land area) of Agricultural land in 1994 to that in 1996?
Your answer should be compact. 0.99. What is the ratio of the Area (% of total land area) in Permanent crop land in 1994 to that in 1996?
Offer a very short reply. 0.97. What is the ratio of the Area (% of total land area) of Terrestrial protected areas in 1994 to that in 1997?
Your answer should be very brief. 0.92. What is the ratio of the Area (% of total land area) in Agricultural land in 1994 to that in 1997?
Your answer should be compact. 0.98. What is the ratio of the Area (% of total land area) of Permanent crop land in 1994 to that in 1997?
Offer a terse response. 0.96. What is the ratio of the Area (% of total land area) in Terrestrial protected areas in 1994 to that in 1998?
Offer a terse response. 0.89. What is the ratio of the Area (% of total land area) in Agricultural land in 1994 to that in 1998?
Provide a succinct answer. 0.97. What is the ratio of the Area (% of total land area) of Arable land in 1994 to that in 1998?
Your response must be concise. 0.98. What is the ratio of the Area (% of total land area) in Permanent crop land in 1994 to that in 1998?
Give a very brief answer. 0.93. What is the ratio of the Area (% of total land area) in Terrestrial protected areas in 1994 to that in 1999?
Provide a short and direct response. 0.87. What is the ratio of the Area (% of total land area) in Agricultural land in 1994 to that in 1999?
Ensure brevity in your answer.  0.96. What is the ratio of the Area (% of total land area) of Arable land in 1994 to that in 1999?
Provide a succinct answer. 0.97. What is the ratio of the Area (% of total land area) of Permanent crop land in 1994 to that in 1999?
Give a very brief answer. 0.92. What is the ratio of the Area (% of total land area) in Terrestrial protected areas in 1994 to that in 2000?
Your response must be concise. 0.82. What is the ratio of the Area (% of total land area) of Agricultural land in 1994 to that in 2000?
Your answer should be very brief. 0.95. What is the ratio of the Area (% of total land area) of Arable land in 1994 to that in 2000?
Offer a terse response. 0.97. What is the ratio of the Area (% of total land area) in Permanent crop land in 1994 to that in 2000?
Offer a very short reply. 0.9. What is the ratio of the Area (% of total land area) of Terrestrial protected areas in 1995 to that in 1996?
Make the answer very short. 0.96. What is the ratio of the Area (% of total land area) of Agricultural land in 1995 to that in 1996?
Your answer should be compact. 0.99. What is the ratio of the Area (% of total land area) in Arable land in 1995 to that in 1996?
Ensure brevity in your answer.  1. What is the ratio of the Area (% of total land area) of Permanent crop land in 1995 to that in 1996?
Offer a very short reply. 0.99. What is the ratio of the Area (% of total land area) in Terrestrial protected areas in 1995 to that in 1997?
Offer a very short reply. 0.93. What is the ratio of the Area (% of total land area) in Agricultural land in 1995 to that in 1997?
Make the answer very short. 0.99. What is the ratio of the Area (% of total land area) of Arable land in 1995 to that in 1997?
Your response must be concise. 0.99. What is the ratio of the Area (% of total land area) in Permanent crop land in 1995 to that in 1997?
Your answer should be very brief. 0.97. What is the ratio of the Area (% of total land area) of Terrestrial protected areas in 1995 to that in 1998?
Keep it short and to the point. 0.9. What is the ratio of the Area (% of total land area) of Agricultural land in 1995 to that in 1998?
Make the answer very short. 0.97. What is the ratio of the Area (% of total land area) in Arable land in 1995 to that in 1998?
Make the answer very short. 0.98. What is the ratio of the Area (% of total land area) of Permanent crop land in 1995 to that in 1998?
Give a very brief answer. 0.95. What is the ratio of the Area (% of total land area) of Terrestrial protected areas in 1995 to that in 1999?
Offer a very short reply. 0.88. What is the ratio of the Area (% of total land area) in Agricultural land in 1995 to that in 1999?
Make the answer very short. 0.97. What is the ratio of the Area (% of total land area) in Arable land in 1995 to that in 1999?
Your answer should be very brief. 0.98. What is the ratio of the Area (% of total land area) of Permanent crop land in 1995 to that in 1999?
Offer a terse response. 0.93. What is the ratio of the Area (% of total land area) in Terrestrial protected areas in 1995 to that in 2000?
Offer a terse response. 0.84. What is the ratio of the Area (% of total land area) of Agricultural land in 1995 to that in 2000?
Give a very brief answer. 0.96. What is the ratio of the Area (% of total land area) of Arable land in 1995 to that in 2000?
Offer a very short reply. 0.97. What is the ratio of the Area (% of total land area) of Permanent crop land in 1995 to that in 2000?
Ensure brevity in your answer.  0.92. What is the ratio of the Area (% of total land area) in Terrestrial protected areas in 1996 to that in 1997?
Make the answer very short. 0.97. What is the ratio of the Area (% of total land area) of Agricultural land in 1996 to that in 1997?
Your answer should be compact. 0.99. What is the ratio of the Area (% of total land area) in Arable land in 1996 to that in 1997?
Ensure brevity in your answer.  0.99. What is the ratio of the Area (% of total land area) of Permanent crop land in 1996 to that in 1997?
Make the answer very short. 0.99. What is the ratio of the Area (% of total land area) in Terrestrial protected areas in 1996 to that in 1998?
Give a very brief answer. 0.94. What is the ratio of the Area (% of total land area) in Agricultural land in 1996 to that in 1998?
Offer a terse response. 0.98. What is the ratio of the Area (% of total land area) of Arable land in 1996 to that in 1998?
Offer a terse response. 0.98. What is the ratio of the Area (% of total land area) of Permanent crop land in 1996 to that in 1998?
Your response must be concise. 0.96. What is the ratio of the Area (% of total land area) in Terrestrial protected areas in 1996 to that in 1999?
Offer a very short reply. 0.91. What is the ratio of the Area (% of total land area) in Agricultural land in 1996 to that in 1999?
Your response must be concise. 0.98. What is the ratio of the Area (% of total land area) in Arable land in 1996 to that in 1999?
Ensure brevity in your answer.  0.98. What is the ratio of the Area (% of total land area) of Permanent crop land in 1996 to that in 1999?
Ensure brevity in your answer.  0.95. What is the ratio of the Area (% of total land area) in Terrestrial protected areas in 1996 to that in 2000?
Offer a very short reply. 0.87. What is the ratio of the Area (% of total land area) in Agricultural land in 1996 to that in 2000?
Provide a short and direct response. 0.97. What is the ratio of the Area (% of total land area) of Arable land in 1996 to that in 2000?
Offer a terse response. 0.97. What is the ratio of the Area (% of total land area) of Permanent crop land in 1996 to that in 2000?
Your answer should be very brief. 0.93. What is the ratio of the Area (% of total land area) in Terrestrial protected areas in 1997 to that in 1998?
Your answer should be compact. 0.97. What is the ratio of the Area (% of total land area) in Agricultural land in 1997 to that in 1998?
Your answer should be compact. 0.99. What is the ratio of the Area (% of total land area) of Permanent crop land in 1997 to that in 1998?
Offer a very short reply. 0.97. What is the ratio of the Area (% of total land area) in Terrestrial protected areas in 1997 to that in 1999?
Your answer should be very brief. 0.94. What is the ratio of the Area (% of total land area) in Agricultural land in 1997 to that in 1999?
Your answer should be very brief. 0.98. What is the ratio of the Area (% of total land area) in Permanent crop land in 1997 to that in 1999?
Offer a terse response. 0.96. What is the ratio of the Area (% of total land area) in Terrestrial protected areas in 1997 to that in 2000?
Offer a terse response. 0.9. What is the ratio of the Area (% of total land area) of Agricultural land in 1997 to that in 2000?
Offer a terse response. 0.97. What is the ratio of the Area (% of total land area) in Arable land in 1997 to that in 2000?
Your answer should be compact. 0.98. What is the ratio of the Area (% of total land area) in Permanent crop land in 1997 to that in 2000?
Ensure brevity in your answer.  0.94. What is the ratio of the Area (% of total land area) of Terrestrial protected areas in 1998 to that in 1999?
Offer a terse response. 0.98. What is the ratio of the Area (% of total land area) of Agricultural land in 1998 to that in 1999?
Offer a terse response. 0.99. What is the ratio of the Area (% of total land area) of Arable land in 1998 to that in 1999?
Provide a short and direct response. 1. What is the ratio of the Area (% of total land area) of Terrestrial protected areas in 1998 to that in 2000?
Provide a succinct answer. 0.93. What is the ratio of the Area (% of total land area) of Agricultural land in 1998 to that in 2000?
Ensure brevity in your answer.  0.99. What is the ratio of the Area (% of total land area) in Arable land in 1998 to that in 2000?
Keep it short and to the point. 0.99. What is the ratio of the Area (% of total land area) in Permanent crop land in 1998 to that in 2000?
Provide a short and direct response. 0.97. What is the ratio of the Area (% of total land area) in Terrestrial protected areas in 1999 to that in 2000?
Make the answer very short. 0.95. What is the ratio of the Area (% of total land area) of Permanent crop land in 1999 to that in 2000?
Offer a terse response. 0.98. What is the difference between the highest and the second highest Area (% of total land area) in Terrestrial protected areas?
Ensure brevity in your answer.  0.55. What is the difference between the highest and the second highest Area (% of total land area) in Agricultural land?
Provide a short and direct response. 0.34. What is the difference between the highest and the second highest Area (% of total land area) in Arable land?
Give a very brief answer. 0.07. What is the difference between the highest and the second highest Area (% of total land area) of Permanent crop land?
Keep it short and to the point. 0.02. What is the difference between the highest and the lowest Area (% of total land area) in Terrestrial protected areas?
Make the answer very short. 2.01. What is the difference between the highest and the lowest Area (% of total land area) in Agricultural land?
Your answer should be very brief. 1.67. What is the difference between the highest and the lowest Area (% of total land area) in Arable land?
Make the answer very short. 0.25. What is the difference between the highest and the lowest Area (% of total land area) in Permanent crop land?
Offer a very short reply. 0.07. 